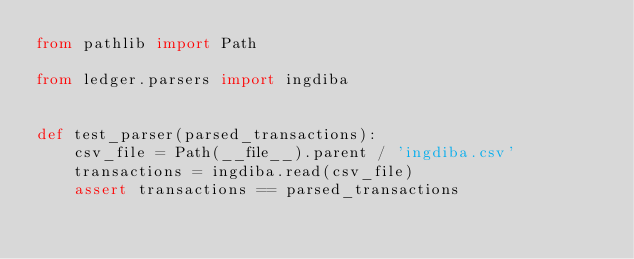<code> <loc_0><loc_0><loc_500><loc_500><_Python_>from pathlib import Path

from ledger.parsers import ingdiba


def test_parser(parsed_transactions):
    csv_file = Path(__file__).parent / 'ingdiba.csv'
    transactions = ingdiba.read(csv_file)
    assert transactions == parsed_transactions
</code> 